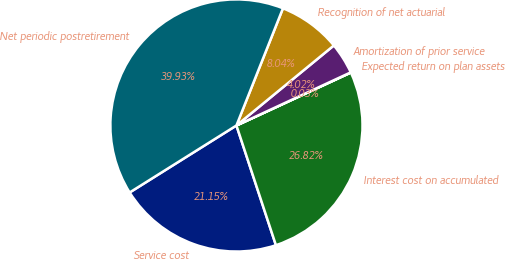<chart> <loc_0><loc_0><loc_500><loc_500><pie_chart><fcel>Service cost<fcel>Interest cost on accumulated<fcel>Expected return on plan assets<fcel>Amortization of prior service<fcel>Recognition of net actuarial<fcel>Net periodic postretirement<nl><fcel>21.15%<fcel>26.82%<fcel>0.03%<fcel>4.02%<fcel>8.04%<fcel>39.93%<nl></chart> 